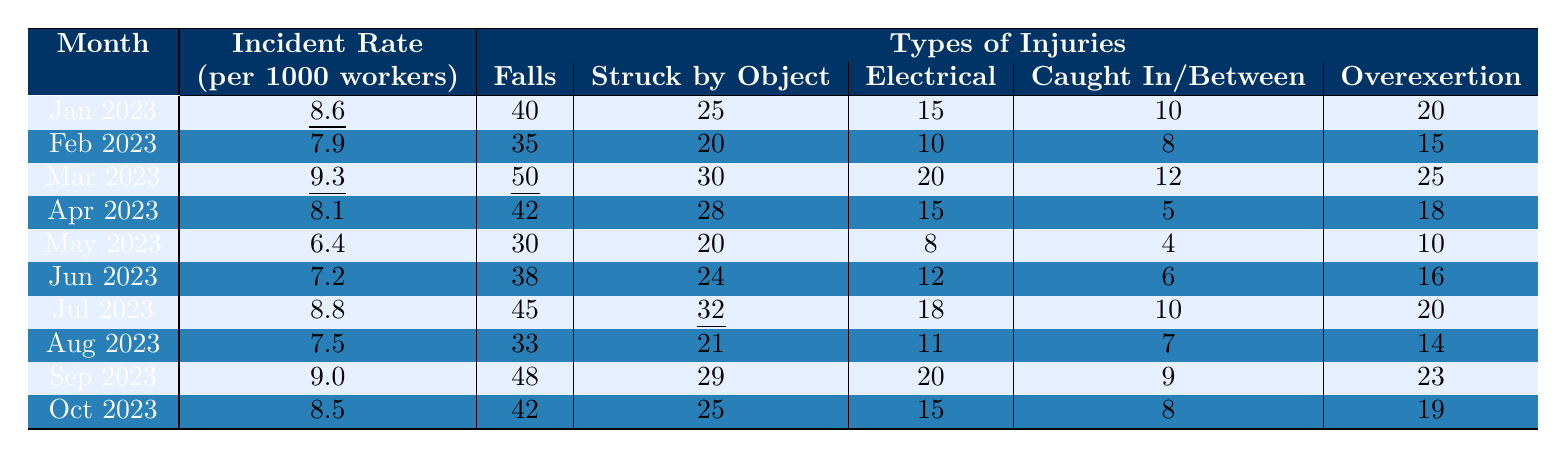What was the incident rate in March 2023? In the table, the incident rate for March 2023 is indicated as 9.3 per 1000 workers.
Answer: 9.3 How many falls were recorded in June 2023? According to the table, the number of falls recorded in June 2023 is 38.
Answer: 38 Which month had the highest incident rate for overexertion injuries? By examining the overexertion column, we find that March 2023 has the highest count of 25.
Answer: March 2023 What is the average incident rate of workplace injuries for the first half of 2023? The incident rates for January to June are 8.6, 7.9, 9.3, 8.1, 6.4, and 7.2. Summing these gives 47.5, and dividing by 6 gives an average of approximately 7.92.
Answer: Approximately 7.92 Did the incident rate decrease from January to May 2023? Comparing the incident rates, January was 8.6 and May was 6.4, which shows a decrease in rates over these months.
Answer: Yes What was the total number of ‘struck by object’ injuries in July and August 2023? In July 2023, there were 32 injuries, and in August 2023, there were 21 injuries. Adding these gives a total of 53.
Answer: 53 Which month had the least number of electrical injuries? The table indicates that May 2023 had the least number of electrical injuries at 8.
Answer: May 2023 Calculate the difference in incident rates between the highest and lowest months. The highest incident rate is 9.3 (March) and the lowest is 6.4 (May). The difference is 9.3 - 6.4 = 2.9.
Answer: 2.9 Is there a month with more than 50 falls recorded? Yes, March 2023 recorded 50 falls, which is the only month with such a high number.
Answer: Yes Across all months, what percentage of injuries were due to falls? The total number of injuries due to falls is 40 + 35 + 50 + 42 + 30 + 38 + 45 + 33 + 48 + 42 = 403. The total incidents can be calculated as 8.6 + 7.9 + 9.3 + 8.1 + 6.4 + 7.2 + 8.8 + 7.5 + 9.0 + 8.5 = 82.8, divided by 10 gives an average of 8.28. The percentage is (403/ (82.8*1000/10))*100 = 48.7%.
Answer: Approximately 48.7% 